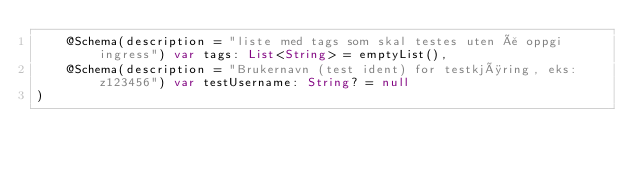Convert code to text. <code><loc_0><loc_0><loc_500><loc_500><_Kotlin_>    @Schema(description = "liste med tags som skal testes uten å oppgi ingress") var tags: List<String> = emptyList(),
    @Schema(description = "Brukernavn (test ident) for testkjøring, eks: z123456") var testUsername: String? = null
)
</code> 